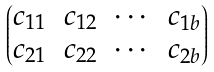Convert formula to latex. <formula><loc_0><loc_0><loc_500><loc_500>\begin{pmatrix} c _ { 1 1 } & c _ { 1 2 } & \cdots & c _ { 1 b } \\ c _ { 2 1 } & c _ { 2 2 } & \cdots & c _ { 2 b } \end{pmatrix}</formula> 